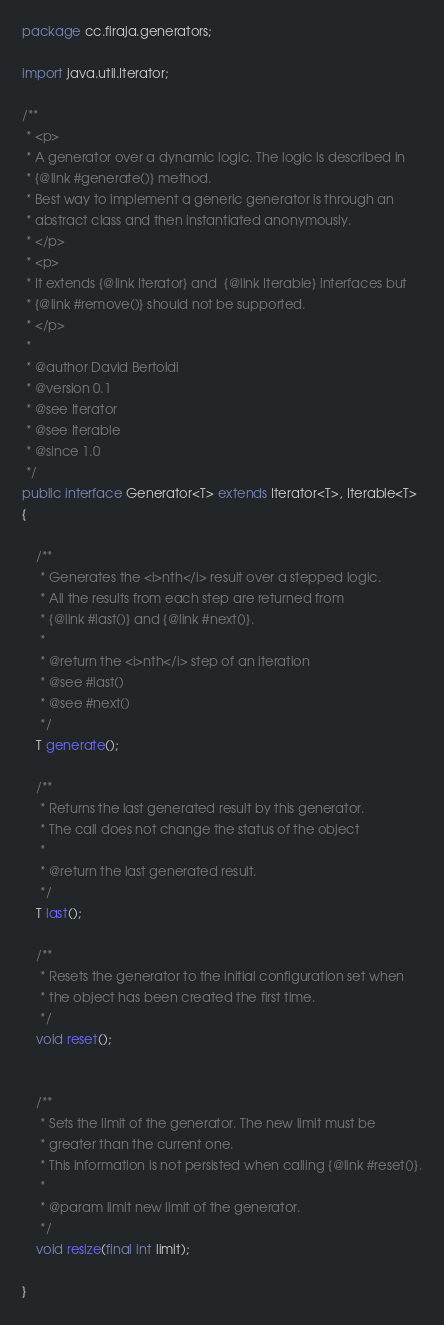Convert code to text. <code><loc_0><loc_0><loc_500><loc_500><_Java_>package cc.firaja.generators;

import java.util.Iterator;

/**
 * <p>
 * A generator over a dynamic logic. The logic is described in
 * {@link #generate()} method.
 * Best way to implement a generic generator is through an
 * abstract class and then instantiated anonymously.
 * </p>
 * <p>
 * It extends {@link Iterator} and  {@link Iterable} interfaces but
 * {@link #remove()} should not be supported.
 * </p>
 *
 * @author David Bertoldi
 * @version 0.1
 * @see Iterator
 * @see Iterable
 * @since 1.0
 */
public interface Generator<T> extends Iterator<T>, Iterable<T>
{

	/**
	 * Generates the <i>nth</i> result over a stepped logic.
	 * All the results from each step are returned from
	 * {@link #last()} and {@link #next()}.
	 *
	 * @return the <i>nth</i> step of an iteration
	 * @see #last()
	 * @see #next()
	 */
	T generate();

	/**
	 * Returns the last generated result by this generator.
	 * The call does not change the status of the object
	 *
	 * @return the last generated result.
	 */
	T last();

	/**
	 * Resets the generator to the initial configuration set when
	 * the object has been created the first time.
	 */
	void reset();


	/**
	 * Sets the limit of the generator. The new limit must be
	 * greater than the current one.
	 * This information is not persisted when calling {@link #reset()}.
	 *
	 * @param limit new limit of the generator.
	 */
	void resize(final int limit);

}
</code> 